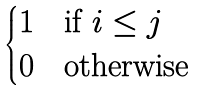<formula> <loc_0><loc_0><loc_500><loc_500>\begin{cases} 1 & \text {if } i \leq j \\ 0 & \text {otherwise} \end{cases}</formula> 